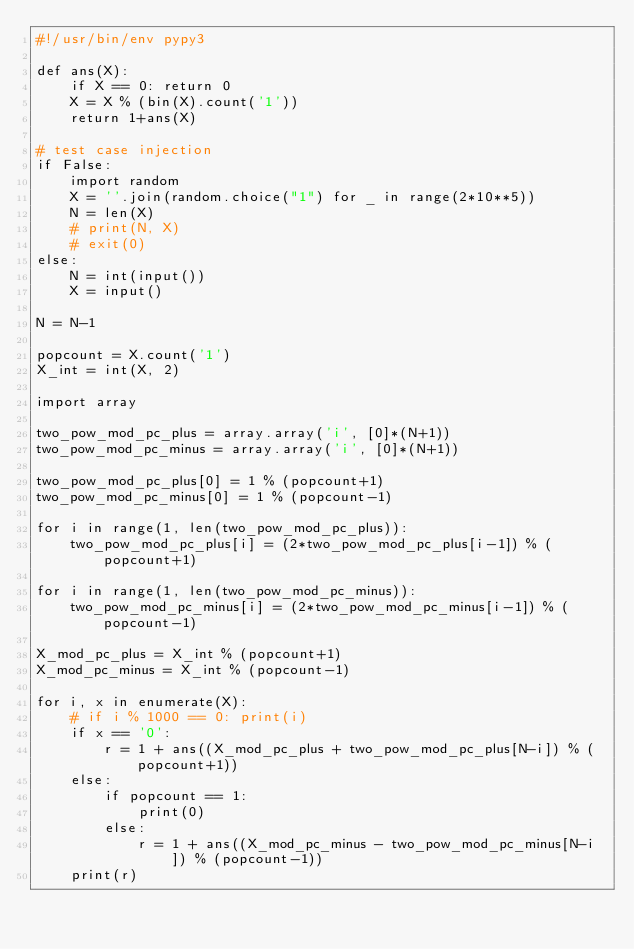<code> <loc_0><loc_0><loc_500><loc_500><_Python_>#!/usr/bin/env pypy3

def ans(X):
    if X == 0: return 0
    X = X % (bin(X).count('1'))
    return 1+ans(X)

# test case injection
if False:
    import random
    X = ''.join(random.choice("1") for _ in range(2*10**5))
    N = len(X)
    # print(N, X)
    # exit(0)
else:
    N = int(input())
    X = input()

N = N-1

popcount = X.count('1')
X_int = int(X, 2)

import array

two_pow_mod_pc_plus = array.array('i', [0]*(N+1))
two_pow_mod_pc_minus = array.array('i', [0]*(N+1))

two_pow_mod_pc_plus[0] = 1 % (popcount+1)
two_pow_mod_pc_minus[0] = 1 % (popcount-1)

for i in range(1, len(two_pow_mod_pc_plus)):
    two_pow_mod_pc_plus[i] = (2*two_pow_mod_pc_plus[i-1]) % (popcount+1)

for i in range(1, len(two_pow_mod_pc_minus)):
    two_pow_mod_pc_minus[i] = (2*two_pow_mod_pc_minus[i-1]) % (popcount-1)

X_mod_pc_plus = X_int % (popcount+1)
X_mod_pc_minus = X_int % (popcount-1)

for i, x in enumerate(X):
    # if i % 1000 == 0: print(i)
    if x == '0':
        r = 1 + ans((X_mod_pc_plus + two_pow_mod_pc_plus[N-i]) % (popcount+1))
    else:
        if popcount == 1:
            print(0)
        else:
            r = 1 + ans((X_mod_pc_minus - two_pow_mod_pc_minus[N-i]) % (popcount-1))
    print(r)
</code> 